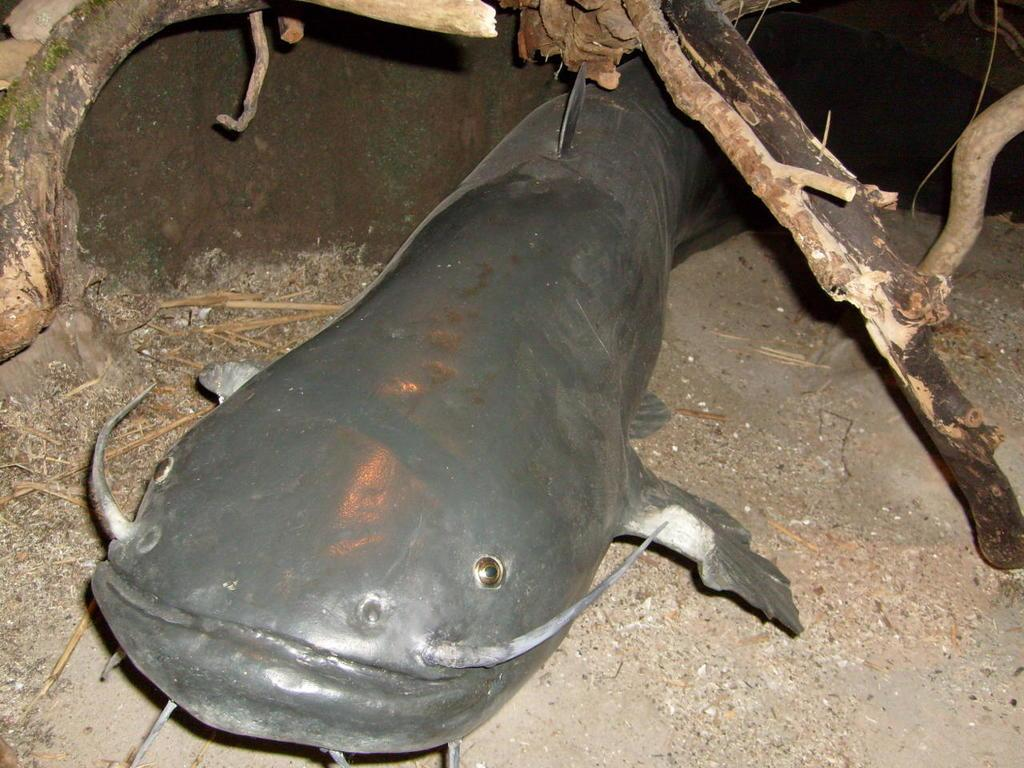What type of animal is on the ground in the image? There is a catfish on the ground in the image. What can be seen on the left side of the image? There are branches visible on the left side of the image. What can be seen on the right side of the image? There are branches visible on the right side of the image. What brand of toothpaste is the catfish using in the image? There is no toothpaste present in the image, and the catfish is not using any toothpaste. 